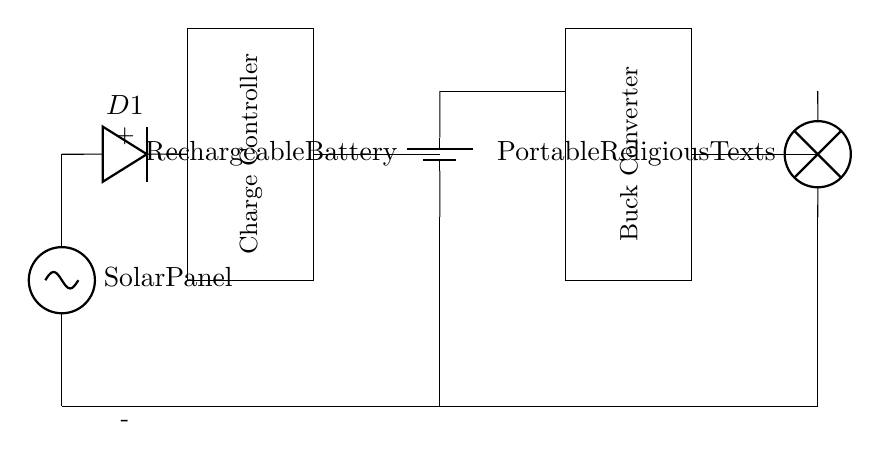What is the main source of power in this circuit? The main source of power is the solar panel, which converts sunlight into electrical energy. This can be identified as it is the first component in the circuit diagram.
Answer: Solar panel What component regulates the charging process for the battery? The charge controller is responsible for regulating the charging of the battery. It is depicted as a rectangular box adjacent to the diode, controlling the flow of current to prevent overcharging.
Answer: Charge controller How many primary components are involved in this circuit? There are five primary components: the solar panel, diode, charge controller, rechargeable battery, and buck converter. Count each distinct component in the circuit diagram to determine the total.
Answer: Five What is the function of the buck converter in this circuit? The buck converter's function is to step down the voltage to the appropriate level for the load (portable religious texts). It is positioned towards the end of the circuit, facilitating the voltage reduction before power reaches the load.
Answer: Step down voltage Which component protects the battery from reverse voltage? The diode (labeled D1) protects the battery from reverse voltage, allowing current to flow in only one direction to prevent damage to the battery from incorrect connections. This is evident from its placement in series with the charge controller and battery.
Answer: Diode What is the output load referred to in the diagram? The output load is referred to as portable religious texts, represented by a lamp symbol in the circuit. This indicates that the circuit is designed to deliver power to a device associated with spiritual texts.
Answer: Portable religious texts 